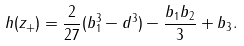<formula> <loc_0><loc_0><loc_500><loc_500>h ( z _ { + } ) = \frac { 2 } { 2 7 } ( b _ { 1 } ^ { 3 } - d ^ { 3 } ) - \frac { b _ { 1 } b _ { 2 } } { 3 } + b _ { 3 } .</formula> 